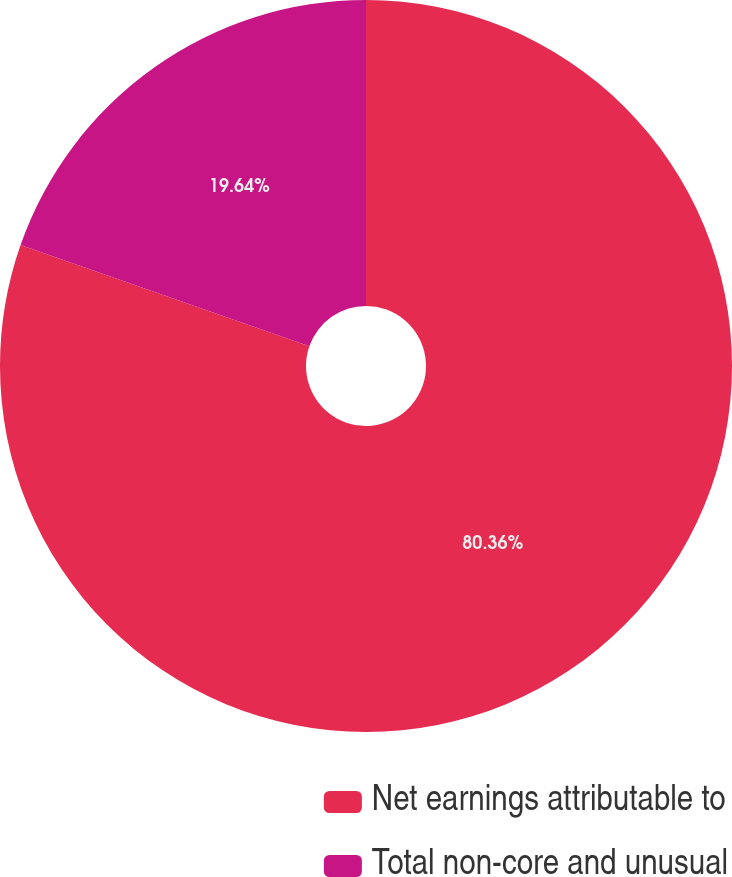<chart> <loc_0><loc_0><loc_500><loc_500><pie_chart><fcel>Net earnings attributable to<fcel>Total non-core and unusual<nl><fcel>80.36%<fcel>19.64%<nl></chart> 